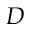<formula> <loc_0><loc_0><loc_500><loc_500>D</formula> 